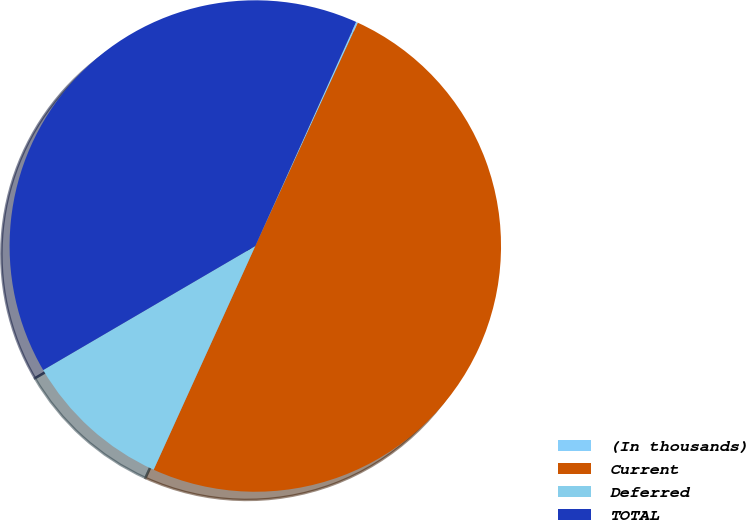Convert chart to OTSL. <chart><loc_0><loc_0><loc_500><loc_500><pie_chart><fcel>(In thousands)<fcel>Current<fcel>Deferred<fcel>TOTAL<nl><fcel>0.12%<fcel>49.94%<fcel>9.79%<fcel>40.15%<nl></chart> 